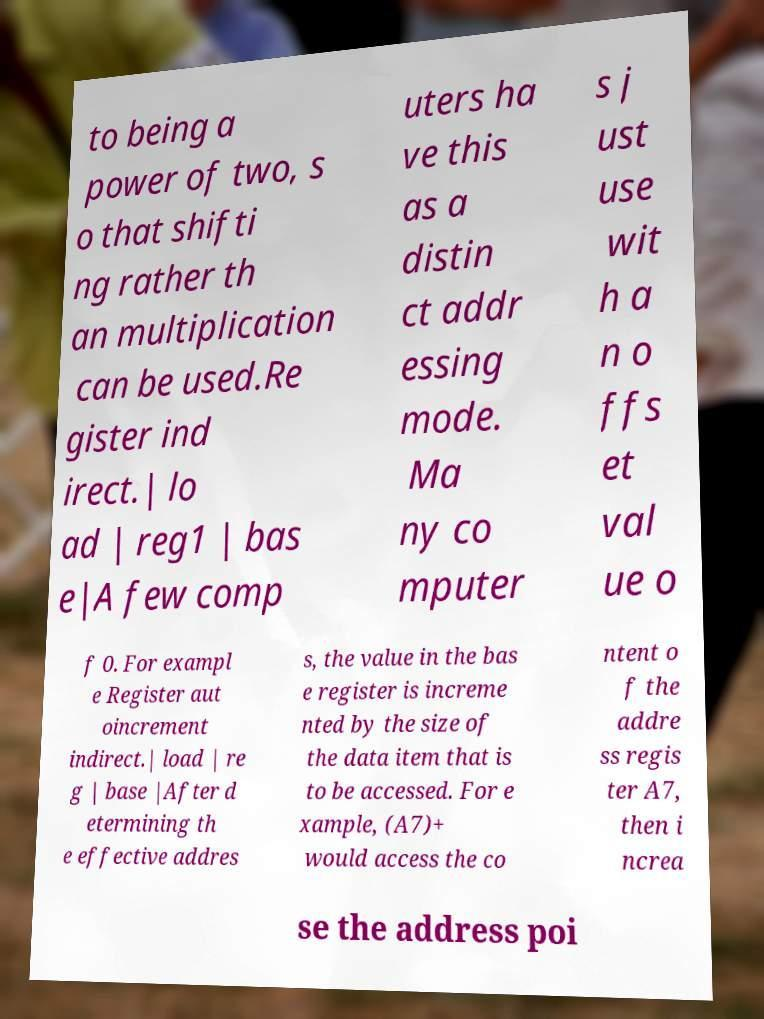Please read and relay the text visible in this image. What does it say? to being a power of two, s o that shifti ng rather th an multiplication can be used.Re gister ind irect.| lo ad | reg1 | bas e|A few comp uters ha ve this as a distin ct addr essing mode. Ma ny co mputer s j ust use wit h a n o ffs et val ue o f 0. For exampl e Register aut oincrement indirect.| load | re g | base |After d etermining th e effective addres s, the value in the bas e register is increme nted by the size of the data item that is to be accessed. For e xample, (A7)+ would access the co ntent o f the addre ss regis ter A7, then i ncrea se the address poi 